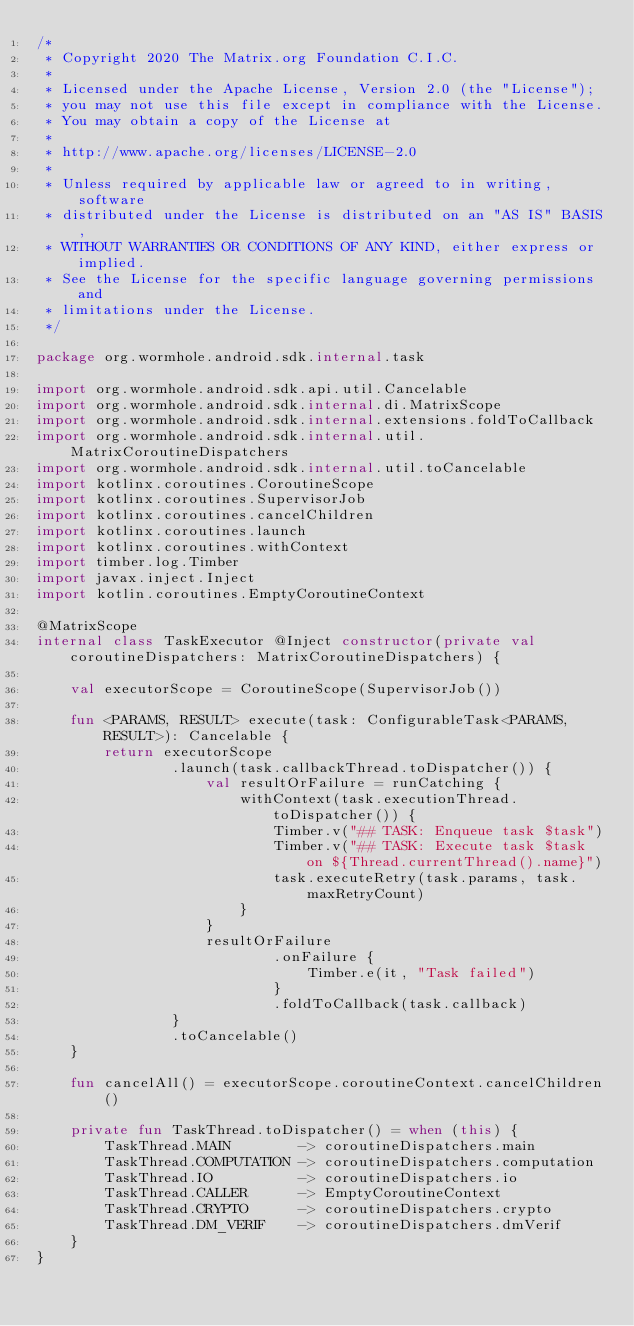<code> <loc_0><loc_0><loc_500><loc_500><_Kotlin_>/*
 * Copyright 2020 The Matrix.org Foundation C.I.C.
 *
 * Licensed under the Apache License, Version 2.0 (the "License");
 * you may not use this file except in compliance with the License.
 * You may obtain a copy of the License at
 *
 * http://www.apache.org/licenses/LICENSE-2.0
 *
 * Unless required by applicable law or agreed to in writing, software
 * distributed under the License is distributed on an "AS IS" BASIS,
 * WITHOUT WARRANTIES OR CONDITIONS OF ANY KIND, either express or implied.
 * See the License for the specific language governing permissions and
 * limitations under the License.
 */

package org.wormhole.android.sdk.internal.task

import org.wormhole.android.sdk.api.util.Cancelable
import org.wormhole.android.sdk.internal.di.MatrixScope
import org.wormhole.android.sdk.internal.extensions.foldToCallback
import org.wormhole.android.sdk.internal.util.MatrixCoroutineDispatchers
import org.wormhole.android.sdk.internal.util.toCancelable
import kotlinx.coroutines.CoroutineScope
import kotlinx.coroutines.SupervisorJob
import kotlinx.coroutines.cancelChildren
import kotlinx.coroutines.launch
import kotlinx.coroutines.withContext
import timber.log.Timber
import javax.inject.Inject
import kotlin.coroutines.EmptyCoroutineContext

@MatrixScope
internal class TaskExecutor @Inject constructor(private val coroutineDispatchers: MatrixCoroutineDispatchers) {

    val executorScope = CoroutineScope(SupervisorJob())

    fun <PARAMS, RESULT> execute(task: ConfigurableTask<PARAMS, RESULT>): Cancelable {
        return executorScope
                .launch(task.callbackThread.toDispatcher()) {
                    val resultOrFailure = runCatching {
                        withContext(task.executionThread.toDispatcher()) {
                            Timber.v("## TASK: Enqueue task $task")
                            Timber.v("## TASK: Execute task $task on ${Thread.currentThread().name}")
                            task.executeRetry(task.params, task.maxRetryCount)
                        }
                    }
                    resultOrFailure
                            .onFailure {
                                Timber.e(it, "Task failed")
                            }
                            .foldToCallback(task.callback)
                }
                .toCancelable()
    }

    fun cancelAll() = executorScope.coroutineContext.cancelChildren()

    private fun TaskThread.toDispatcher() = when (this) {
        TaskThread.MAIN        -> coroutineDispatchers.main
        TaskThread.COMPUTATION -> coroutineDispatchers.computation
        TaskThread.IO          -> coroutineDispatchers.io
        TaskThread.CALLER      -> EmptyCoroutineContext
        TaskThread.CRYPTO      -> coroutineDispatchers.crypto
        TaskThread.DM_VERIF    -> coroutineDispatchers.dmVerif
    }
}
</code> 